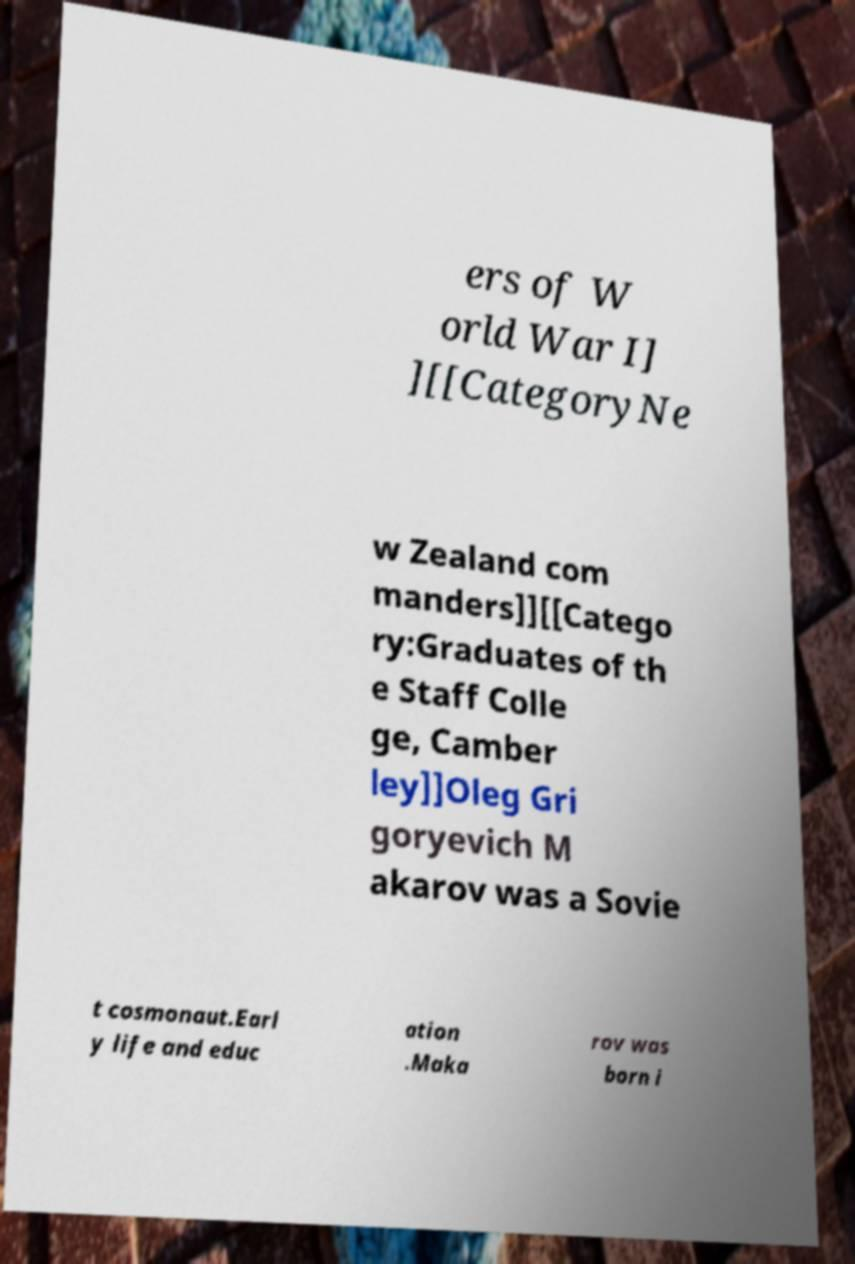Could you extract and type out the text from this image? ers of W orld War I] ][[CategoryNe w Zealand com manders]][[Catego ry:Graduates of th e Staff Colle ge, Camber ley]]Oleg Gri goryevich M akarov was a Sovie t cosmonaut.Earl y life and educ ation .Maka rov was born i 